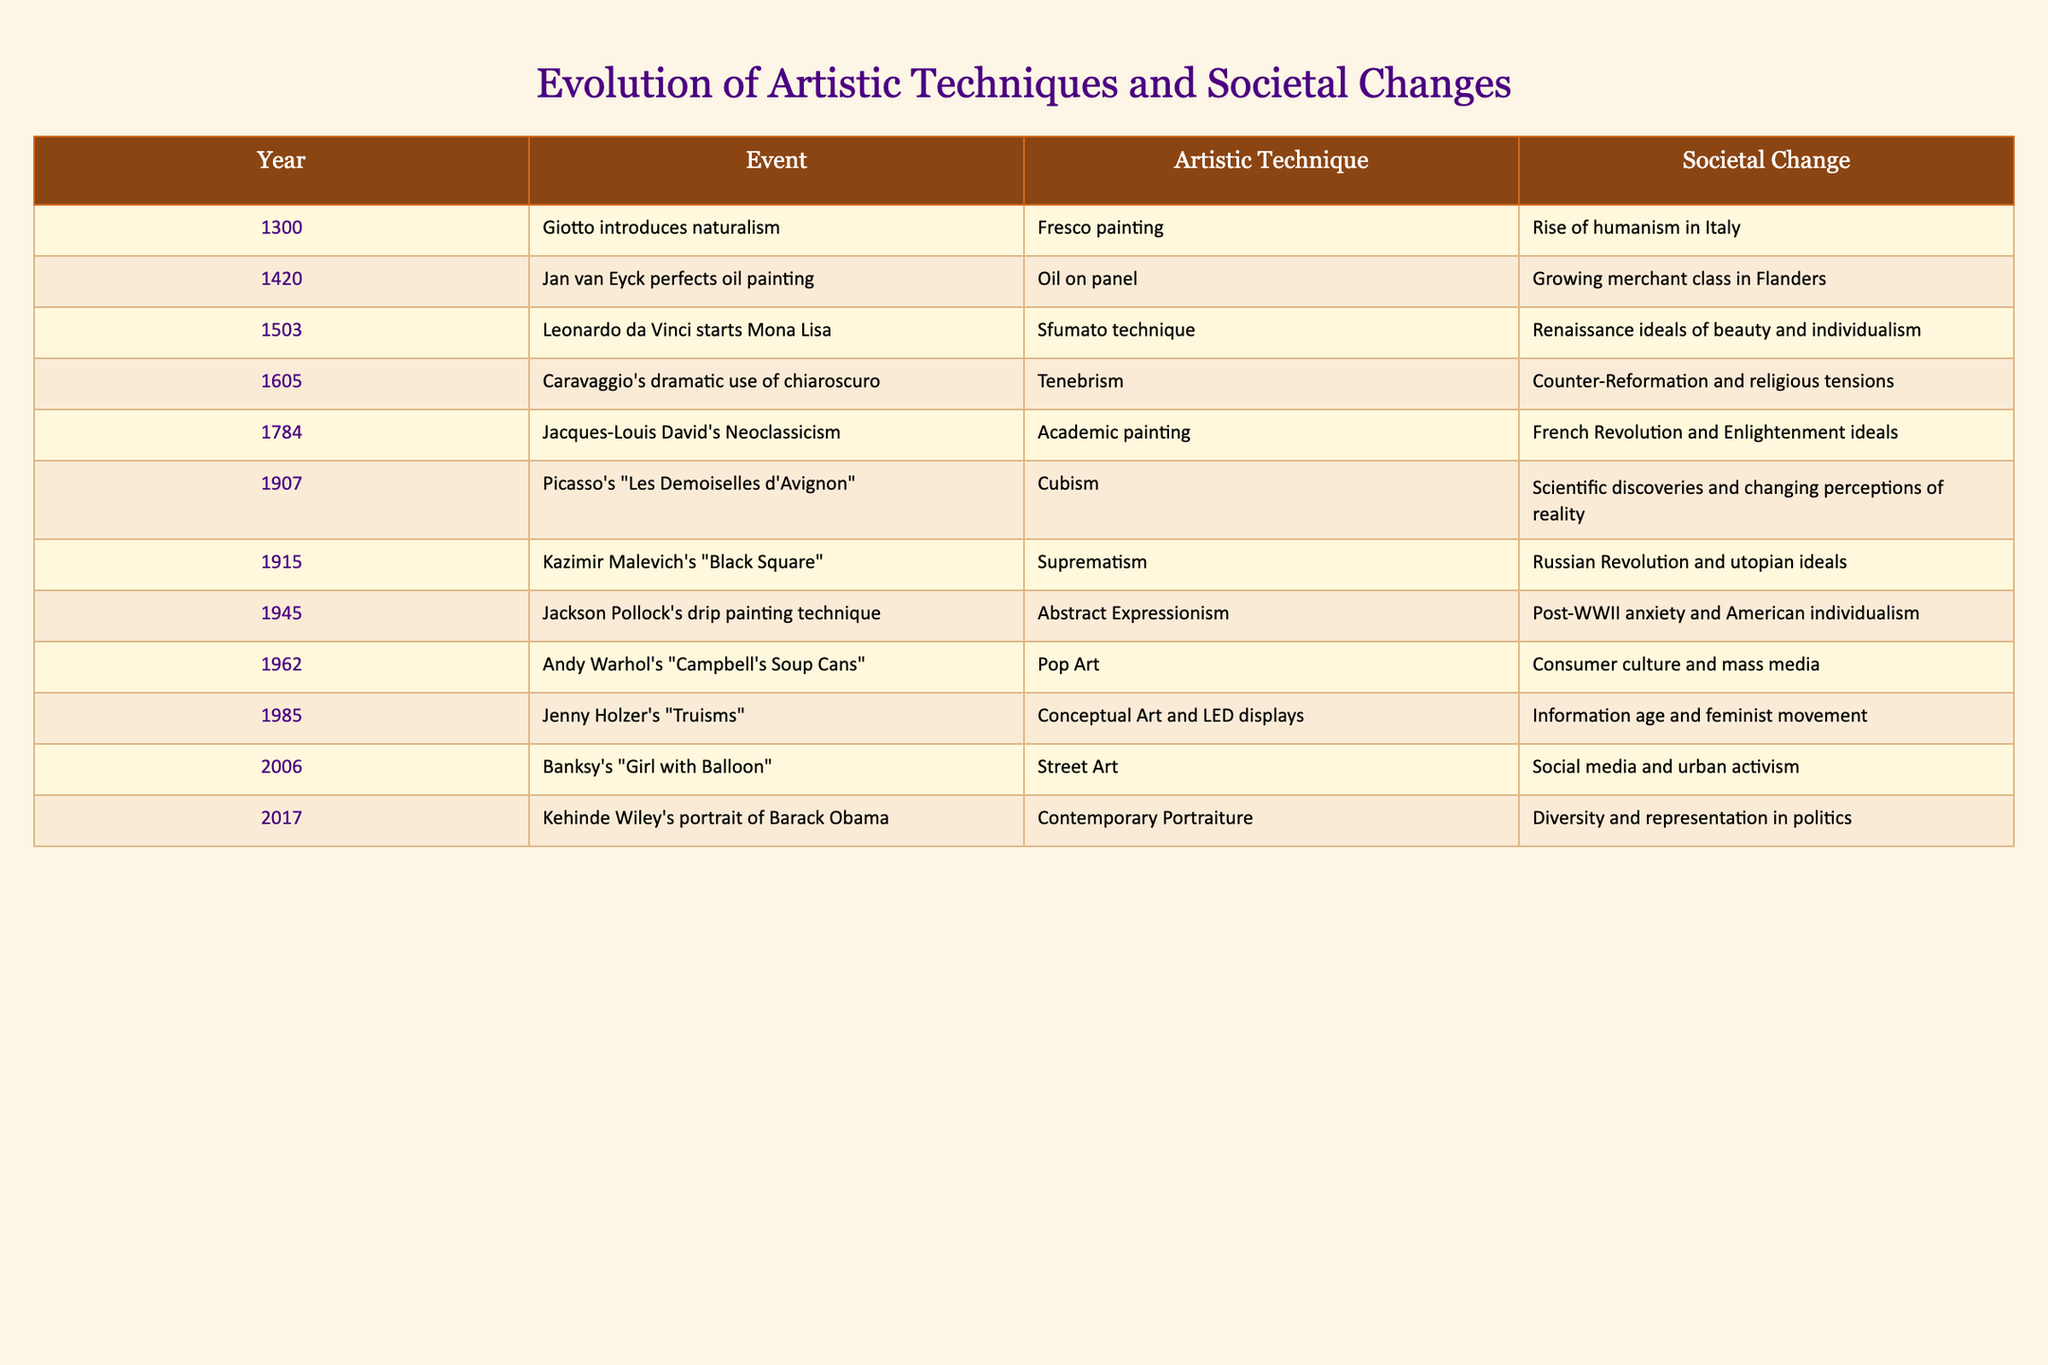What artistic technique did Giotto introduce in 1300? From the table, it states that in 1300, Giotto introduced naturalism, which is associated with fresco painting.
Answer: Fresco painting Which year marks the introduction of the Sfumato technique by Leonardo da Vinci? The table shows that Leonardo da Vinci started working on the Mona Lisa in the year 1503, signifying the introduction of the Sfumato technique.
Answer: 1503 True or False: Caravaggio's work reflects the Counter-Reformation and religious tensions. The table confirms that Caravaggio's dramatic use of chiaroscuro in 1605 is related to the Counter-Reformation and religious tensions, making the statement true.
Answer: True How many years are between Picasso's introduction of Cubism in 1907 and Kazimir Malevich's Suprematism in 1915? By subtracting the year of Cubism (1907) from the year of Suprematism (1915), the difference is 1915 - 1907 = 8 years.
Answer: 8 years What societal change is associated with Jackson Pollock's Abstract Expressionism? The table indicates that Jackson Pollock's drip painting technique in 1945 is linked to post-WWII anxiety and American individualism.
Answer: Post-WWII anxiety and American individualism Which artistic techniques were introduced during the French Revolution and Enlightenment ideals? From the table, Jacques-Louis David's Neoclassicism introduced academic painting in 1784 during the French Revolution and Enlightenment ideals. Therefore, the artistic techniques are Neoclassicism and academic painting.
Answer: Neoclassicism and academic painting Which artistic technique reflects changing perceptions of reality in the early 20th century? The table identifies that Cubism, introduced by Picasso in 1907, reflects scientific discoveries and changing perceptions of reality, thus being the artistic technique connected to this societal change.
Answer: Cubism If we consider the years in which Pop Art and Conceptual Art were introduced, what is the total number of years between Andy Warhol's work in 1962 and Jenny Holzer's work in 1985? Subtracting the year of Warhol's Pop Art (1962) from Holzer's Conceptual Art (1985) gives us 1985 - 1962 = 23 years.
Answer: 23 years 